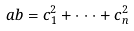Convert formula to latex. <formula><loc_0><loc_0><loc_500><loc_500>a b = c _ { 1 } ^ { 2 } + \cdot \cdot \cdot + c _ { n } ^ { 2 }</formula> 